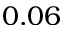Convert formula to latex. <formula><loc_0><loc_0><loc_500><loc_500>0 . 0 6</formula> 